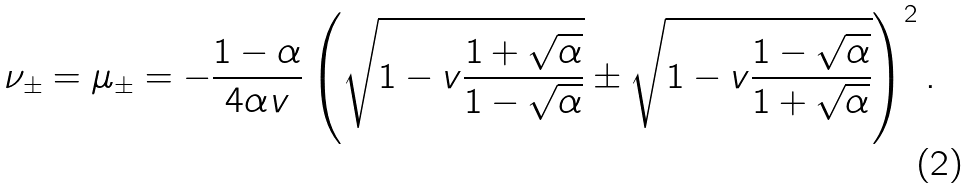<formula> <loc_0><loc_0><loc_500><loc_500>\nu _ { \pm } = \mu _ { \pm } = - \frac { 1 - \alpha } { 4 \alpha v } \left ( \sqrt { 1 - v \frac { 1 + \sqrt { \alpha } } { 1 - \sqrt { \alpha } } } \pm \sqrt { 1 - v \frac { 1 - \sqrt { \alpha } } { 1 + \sqrt { \alpha } } } \right ) ^ { 2 } .</formula> 